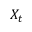<formula> <loc_0><loc_0><loc_500><loc_500>X _ { t }</formula> 